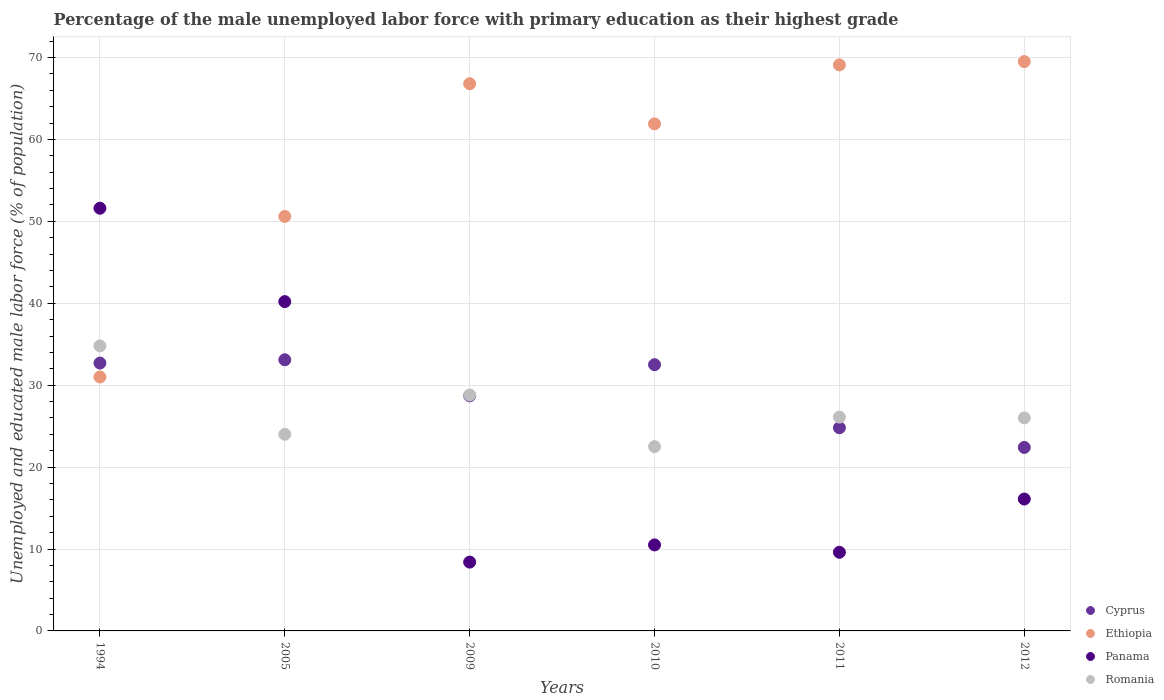What is the percentage of the unemployed male labor force with primary education in Romania in 2012?
Ensure brevity in your answer.  26. Across all years, what is the maximum percentage of the unemployed male labor force with primary education in Panama?
Provide a short and direct response. 51.6. Across all years, what is the minimum percentage of the unemployed male labor force with primary education in Ethiopia?
Give a very brief answer. 31. In which year was the percentage of the unemployed male labor force with primary education in Ethiopia maximum?
Your answer should be very brief. 2012. In which year was the percentage of the unemployed male labor force with primary education in Ethiopia minimum?
Make the answer very short. 1994. What is the total percentage of the unemployed male labor force with primary education in Romania in the graph?
Your answer should be very brief. 162.2. What is the difference between the percentage of the unemployed male labor force with primary education in Ethiopia in 1994 and that in 2010?
Provide a short and direct response. -30.9. What is the difference between the percentage of the unemployed male labor force with primary education in Panama in 2009 and the percentage of the unemployed male labor force with primary education in Cyprus in 2012?
Provide a short and direct response. -14. What is the average percentage of the unemployed male labor force with primary education in Cyprus per year?
Provide a succinct answer. 29.03. In the year 2012, what is the difference between the percentage of the unemployed male labor force with primary education in Panama and percentage of the unemployed male labor force with primary education in Cyprus?
Your answer should be compact. -6.3. What is the ratio of the percentage of the unemployed male labor force with primary education in Panama in 2010 to that in 2012?
Give a very brief answer. 0.65. Is the percentage of the unemployed male labor force with primary education in Panama in 2005 less than that in 2011?
Make the answer very short. No. Is the difference between the percentage of the unemployed male labor force with primary education in Panama in 2010 and 2011 greater than the difference between the percentage of the unemployed male labor force with primary education in Cyprus in 2010 and 2011?
Your answer should be compact. No. What is the difference between the highest and the second highest percentage of the unemployed male labor force with primary education in Ethiopia?
Keep it short and to the point. 0.4. What is the difference between the highest and the lowest percentage of the unemployed male labor force with primary education in Panama?
Your response must be concise. 43.2. In how many years, is the percentage of the unemployed male labor force with primary education in Romania greater than the average percentage of the unemployed male labor force with primary education in Romania taken over all years?
Ensure brevity in your answer.  2. Is the sum of the percentage of the unemployed male labor force with primary education in Ethiopia in 2005 and 2011 greater than the maximum percentage of the unemployed male labor force with primary education in Romania across all years?
Keep it short and to the point. Yes. Is it the case that in every year, the sum of the percentage of the unemployed male labor force with primary education in Ethiopia and percentage of the unemployed male labor force with primary education in Cyprus  is greater than the sum of percentage of the unemployed male labor force with primary education in Panama and percentage of the unemployed male labor force with primary education in Romania?
Keep it short and to the point. Yes. Is it the case that in every year, the sum of the percentage of the unemployed male labor force with primary education in Ethiopia and percentage of the unemployed male labor force with primary education in Panama  is greater than the percentage of the unemployed male labor force with primary education in Cyprus?
Your response must be concise. Yes. Does the percentage of the unemployed male labor force with primary education in Ethiopia monotonically increase over the years?
Provide a succinct answer. No. Is the percentage of the unemployed male labor force with primary education in Cyprus strictly greater than the percentage of the unemployed male labor force with primary education in Ethiopia over the years?
Offer a very short reply. No. How many dotlines are there?
Give a very brief answer. 4. Are the values on the major ticks of Y-axis written in scientific E-notation?
Ensure brevity in your answer.  No. Does the graph contain grids?
Ensure brevity in your answer.  Yes. Where does the legend appear in the graph?
Keep it short and to the point. Bottom right. How many legend labels are there?
Keep it short and to the point. 4. What is the title of the graph?
Offer a very short reply. Percentage of the male unemployed labor force with primary education as their highest grade. Does "Angola" appear as one of the legend labels in the graph?
Keep it short and to the point. No. What is the label or title of the Y-axis?
Provide a succinct answer. Unemployed and educated male labor force (% of population). What is the Unemployed and educated male labor force (% of population) of Cyprus in 1994?
Provide a short and direct response. 32.7. What is the Unemployed and educated male labor force (% of population) in Panama in 1994?
Offer a terse response. 51.6. What is the Unemployed and educated male labor force (% of population) of Romania in 1994?
Give a very brief answer. 34.8. What is the Unemployed and educated male labor force (% of population) of Cyprus in 2005?
Your answer should be compact. 33.1. What is the Unemployed and educated male labor force (% of population) in Ethiopia in 2005?
Your answer should be very brief. 50.6. What is the Unemployed and educated male labor force (% of population) of Panama in 2005?
Provide a succinct answer. 40.2. What is the Unemployed and educated male labor force (% of population) of Cyprus in 2009?
Your answer should be compact. 28.7. What is the Unemployed and educated male labor force (% of population) in Ethiopia in 2009?
Give a very brief answer. 66.8. What is the Unemployed and educated male labor force (% of population) of Panama in 2009?
Provide a short and direct response. 8.4. What is the Unemployed and educated male labor force (% of population) in Romania in 2009?
Offer a terse response. 28.8. What is the Unemployed and educated male labor force (% of population) of Cyprus in 2010?
Make the answer very short. 32.5. What is the Unemployed and educated male labor force (% of population) in Ethiopia in 2010?
Provide a short and direct response. 61.9. What is the Unemployed and educated male labor force (% of population) in Romania in 2010?
Your answer should be compact. 22.5. What is the Unemployed and educated male labor force (% of population) in Cyprus in 2011?
Offer a terse response. 24.8. What is the Unemployed and educated male labor force (% of population) of Ethiopia in 2011?
Provide a short and direct response. 69.1. What is the Unemployed and educated male labor force (% of population) in Panama in 2011?
Give a very brief answer. 9.6. What is the Unemployed and educated male labor force (% of population) in Romania in 2011?
Give a very brief answer. 26.1. What is the Unemployed and educated male labor force (% of population) of Cyprus in 2012?
Your answer should be compact. 22.4. What is the Unemployed and educated male labor force (% of population) in Ethiopia in 2012?
Keep it short and to the point. 69.5. What is the Unemployed and educated male labor force (% of population) of Panama in 2012?
Ensure brevity in your answer.  16.1. What is the Unemployed and educated male labor force (% of population) of Romania in 2012?
Ensure brevity in your answer.  26. Across all years, what is the maximum Unemployed and educated male labor force (% of population) in Cyprus?
Your answer should be compact. 33.1. Across all years, what is the maximum Unemployed and educated male labor force (% of population) of Ethiopia?
Give a very brief answer. 69.5. Across all years, what is the maximum Unemployed and educated male labor force (% of population) of Panama?
Ensure brevity in your answer.  51.6. Across all years, what is the maximum Unemployed and educated male labor force (% of population) in Romania?
Offer a terse response. 34.8. Across all years, what is the minimum Unemployed and educated male labor force (% of population) in Cyprus?
Ensure brevity in your answer.  22.4. Across all years, what is the minimum Unemployed and educated male labor force (% of population) of Ethiopia?
Offer a very short reply. 31. Across all years, what is the minimum Unemployed and educated male labor force (% of population) of Panama?
Give a very brief answer. 8.4. What is the total Unemployed and educated male labor force (% of population) of Cyprus in the graph?
Provide a succinct answer. 174.2. What is the total Unemployed and educated male labor force (% of population) of Ethiopia in the graph?
Give a very brief answer. 348.9. What is the total Unemployed and educated male labor force (% of population) of Panama in the graph?
Your answer should be compact. 136.4. What is the total Unemployed and educated male labor force (% of population) in Romania in the graph?
Ensure brevity in your answer.  162.2. What is the difference between the Unemployed and educated male labor force (% of population) in Ethiopia in 1994 and that in 2005?
Your answer should be very brief. -19.6. What is the difference between the Unemployed and educated male labor force (% of population) in Romania in 1994 and that in 2005?
Your answer should be very brief. 10.8. What is the difference between the Unemployed and educated male labor force (% of population) in Ethiopia in 1994 and that in 2009?
Offer a terse response. -35.8. What is the difference between the Unemployed and educated male labor force (% of population) in Panama in 1994 and that in 2009?
Provide a succinct answer. 43.2. What is the difference between the Unemployed and educated male labor force (% of population) in Romania in 1994 and that in 2009?
Offer a very short reply. 6. What is the difference between the Unemployed and educated male labor force (% of population) of Cyprus in 1994 and that in 2010?
Keep it short and to the point. 0.2. What is the difference between the Unemployed and educated male labor force (% of population) of Ethiopia in 1994 and that in 2010?
Your response must be concise. -30.9. What is the difference between the Unemployed and educated male labor force (% of population) of Panama in 1994 and that in 2010?
Offer a very short reply. 41.1. What is the difference between the Unemployed and educated male labor force (% of population) in Romania in 1994 and that in 2010?
Your answer should be compact. 12.3. What is the difference between the Unemployed and educated male labor force (% of population) in Cyprus in 1994 and that in 2011?
Offer a terse response. 7.9. What is the difference between the Unemployed and educated male labor force (% of population) in Ethiopia in 1994 and that in 2011?
Make the answer very short. -38.1. What is the difference between the Unemployed and educated male labor force (% of population) of Panama in 1994 and that in 2011?
Your answer should be compact. 42. What is the difference between the Unemployed and educated male labor force (% of population) of Ethiopia in 1994 and that in 2012?
Offer a very short reply. -38.5. What is the difference between the Unemployed and educated male labor force (% of population) of Panama in 1994 and that in 2012?
Your response must be concise. 35.5. What is the difference between the Unemployed and educated male labor force (% of population) in Cyprus in 2005 and that in 2009?
Offer a very short reply. 4.4. What is the difference between the Unemployed and educated male labor force (% of population) in Ethiopia in 2005 and that in 2009?
Give a very brief answer. -16.2. What is the difference between the Unemployed and educated male labor force (% of population) in Panama in 2005 and that in 2009?
Provide a succinct answer. 31.8. What is the difference between the Unemployed and educated male labor force (% of population) of Romania in 2005 and that in 2009?
Your answer should be compact. -4.8. What is the difference between the Unemployed and educated male labor force (% of population) of Ethiopia in 2005 and that in 2010?
Offer a very short reply. -11.3. What is the difference between the Unemployed and educated male labor force (% of population) in Panama in 2005 and that in 2010?
Make the answer very short. 29.7. What is the difference between the Unemployed and educated male labor force (% of population) in Cyprus in 2005 and that in 2011?
Offer a terse response. 8.3. What is the difference between the Unemployed and educated male labor force (% of population) in Ethiopia in 2005 and that in 2011?
Your answer should be compact. -18.5. What is the difference between the Unemployed and educated male labor force (% of population) in Panama in 2005 and that in 2011?
Make the answer very short. 30.6. What is the difference between the Unemployed and educated male labor force (% of population) of Romania in 2005 and that in 2011?
Ensure brevity in your answer.  -2.1. What is the difference between the Unemployed and educated male labor force (% of population) of Ethiopia in 2005 and that in 2012?
Your answer should be very brief. -18.9. What is the difference between the Unemployed and educated male labor force (% of population) in Panama in 2005 and that in 2012?
Your response must be concise. 24.1. What is the difference between the Unemployed and educated male labor force (% of population) in Cyprus in 2009 and that in 2010?
Your answer should be compact. -3.8. What is the difference between the Unemployed and educated male labor force (% of population) in Ethiopia in 2009 and that in 2010?
Offer a terse response. 4.9. What is the difference between the Unemployed and educated male labor force (% of population) in Romania in 2009 and that in 2010?
Give a very brief answer. 6.3. What is the difference between the Unemployed and educated male labor force (% of population) of Cyprus in 2009 and that in 2011?
Offer a very short reply. 3.9. What is the difference between the Unemployed and educated male labor force (% of population) of Panama in 2009 and that in 2011?
Provide a short and direct response. -1.2. What is the difference between the Unemployed and educated male labor force (% of population) of Romania in 2009 and that in 2011?
Offer a very short reply. 2.7. What is the difference between the Unemployed and educated male labor force (% of population) in Panama in 2010 and that in 2011?
Keep it short and to the point. 0.9. What is the difference between the Unemployed and educated male labor force (% of population) of Romania in 2010 and that in 2011?
Provide a short and direct response. -3.6. What is the difference between the Unemployed and educated male labor force (% of population) in Romania in 2010 and that in 2012?
Your answer should be compact. -3.5. What is the difference between the Unemployed and educated male labor force (% of population) of Panama in 2011 and that in 2012?
Provide a succinct answer. -6.5. What is the difference between the Unemployed and educated male labor force (% of population) in Romania in 2011 and that in 2012?
Give a very brief answer. 0.1. What is the difference between the Unemployed and educated male labor force (% of population) of Cyprus in 1994 and the Unemployed and educated male labor force (% of population) of Ethiopia in 2005?
Offer a very short reply. -17.9. What is the difference between the Unemployed and educated male labor force (% of population) of Cyprus in 1994 and the Unemployed and educated male labor force (% of population) of Romania in 2005?
Provide a succinct answer. 8.7. What is the difference between the Unemployed and educated male labor force (% of population) of Ethiopia in 1994 and the Unemployed and educated male labor force (% of population) of Panama in 2005?
Ensure brevity in your answer.  -9.2. What is the difference between the Unemployed and educated male labor force (% of population) of Ethiopia in 1994 and the Unemployed and educated male labor force (% of population) of Romania in 2005?
Provide a succinct answer. 7. What is the difference between the Unemployed and educated male labor force (% of population) in Panama in 1994 and the Unemployed and educated male labor force (% of population) in Romania in 2005?
Offer a terse response. 27.6. What is the difference between the Unemployed and educated male labor force (% of population) of Cyprus in 1994 and the Unemployed and educated male labor force (% of population) of Ethiopia in 2009?
Make the answer very short. -34.1. What is the difference between the Unemployed and educated male labor force (% of population) of Cyprus in 1994 and the Unemployed and educated male labor force (% of population) of Panama in 2009?
Your answer should be compact. 24.3. What is the difference between the Unemployed and educated male labor force (% of population) of Ethiopia in 1994 and the Unemployed and educated male labor force (% of population) of Panama in 2009?
Provide a succinct answer. 22.6. What is the difference between the Unemployed and educated male labor force (% of population) of Panama in 1994 and the Unemployed and educated male labor force (% of population) of Romania in 2009?
Ensure brevity in your answer.  22.8. What is the difference between the Unemployed and educated male labor force (% of population) in Cyprus in 1994 and the Unemployed and educated male labor force (% of population) in Ethiopia in 2010?
Offer a terse response. -29.2. What is the difference between the Unemployed and educated male labor force (% of population) in Cyprus in 1994 and the Unemployed and educated male labor force (% of population) in Panama in 2010?
Give a very brief answer. 22.2. What is the difference between the Unemployed and educated male labor force (% of population) of Cyprus in 1994 and the Unemployed and educated male labor force (% of population) of Romania in 2010?
Your response must be concise. 10.2. What is the difference between the Unemployed and educated male labor force (% of population) in Ethiopia in 1994 and the Unemployed and educated male labor force (% of population) in Romania in 2010?
Offer a very short reply. 8.5. What is the difference between the Unemployed and educated male labor force (% of population) of Panama in 1994 and the Unemployed and educated male labor force (% of population) of Romania in 2010?
Make the answer very short. 29.1. What is the difference between the Unemployed and educated male labor force (% of population) of Cyprus in 1994 and the Unemployed and educated male labor force (% of population) of Ethiopia in 2011?
Offer a very short reply. -36.4. What is the difference between the Unemployed and educated male labor force (% of population) in Cyprus in 1994 and the Unemployed and educated male labor force (% of population) in Panama in 2011?
Provide a succinct answer. 23.1. What is the difference between the Unemployed and educated male labor force (% of population) in Ethiopia in 1994 and the Unemployed and educated male labor force (% of population) in Panama in 2011?
Make the answer very short. 21.4. What is the difference between the Unemployed and educated male labor force (% of population) in Cyprus in 1994 and the Unemployed and educated male labor force (% of population) in Ethiopia in 2012?
Keep it short and to the point. -36.8. What is the difference between the Unemployed and educated male labor force (% of population) of Ethiopia in 1994 and the Unemployed and educated male labor force (% of population) of Panama in 2012?
Provide a succinct answer. 14.9. What is the difference between the Unemployed and educated male labor force (% of population) in Ethiopia in 1994 and the Unemployed and educated male labor force (% of population) in Romania in 2012?
Give a very brief answer. 5. What is the difference between the Unemployed and educated male labor force (% of population) of Panama in 1994 and the Unemployed and educated male labor force (% of population) of Romania in 2012?
Ensure brevity in your answer.  25.6. What is the difference between the Unemployed and educated male labor force (% of population) of Cyprus in 2005 and the Unemployed and educated male labor force (% of population) of Ethiopia in 2009?
Make the answer very short. -33.7. What is the difference between the Unemployed and educated male labor force (% of population) in Cyprus in 2005 and the Unemployed and educated male labor force (% of population) in Panama in 2009?
Your response must be concise. 24.7. What is the difference between the Unemployed and educated male labor force (% of population) in Cyprus in 2005 and the Unemployed and educated male labor force (% of population) in Romania in 2009?
Provide a succinct answer. 4.3. What is the difference between the Unemployed and educated male labor force (% of population) of Ethiopia in 2005 and the Unemployed and educated male labor force (% of population) of Panama in 2009?
Provide a succinct answer. 42.2. What is the difference between the Unemployed and educated male labor force (% of population) of Ethiopia in 2005 and the Unemployed and educated male labor force (% of population) of Romania in 2009?
Your answer should be very brief. 21.8. What is the difference between the Unemployed and educated male labor force (% of population) in Panama in 2005 and the Unemployed and educated male labor force (% of population) in Romania in 2009?
Your answer should be compact. 11.4. What is the difference between the Unemployed and educated male labor force (% of population) in Cyprus in 2005 and the Unemployed and educated male labor force (% of population) in Ethiopia in 2010?
Give a very brief answer. -28.8. What is the difference between the Unemployed and educated male labor force (% of population) of Cyprus in 2005 and the Unemployed and educated male labor force (% of population) of Panama in 2010?
Your answer should be compact. 22.6. What is the difference between the Unemployed and educated male labor force (% of population) in Ethiopia in 2005 and the Unemployed and educated male labor force (% of population) in Panama in 2010?
Make the answer very short. 40.1. What is the difference between the Unemployed and educated male labor force (% of population) of Ethiopia in 2005 and the Unemployed and educated male labor force (% of population) of Romania in 2010?
Provide a succinct answer. 28.1. What is the difference between the Unemployed and educated male labor force (% of population) of Cyprus in 2005 and the Unemployed and educated male labor force (% of population) of Ethiopia in 2011?
Offer a very short reply. -36. What is the difference between the Unemployed and educated male labor force (% of population) of Cyprus in 2005 and the Unemployed and educated male labor force (% of population) of Panama in 2011?
Offer a terse response. 23.5. What is the difference between the Unemployed and educated male labor force (% of population) in Panama in 2005 and the Unemployed and educated male labor force (% of population) in Romania in 2011?
Give a very brief answer. 14.1. What is the difference between the Unemployed and educated male labor force (% of population) of Cyprus in 2005 and the Unemployed and educated male labor force (% of population) of Ethiopia in 2012?
Make the answer very short. -36.4. What is the difference between the Unemployed and educated male labor force (% of population) in Cyprus in 2005 and the Unemployed and educated male labor force (% of population) in Romania in 2012?
Your answer should be very brief. 7.1. What is the difference between the Unemployed and educated male labor force (% of population) of Ethiopia in 2005 and the Unemployed and educated male labor force (% of population) of Panama in 2012?
Offer a terse response. 34.5. What is the difference between the Unemployed and educated male labor force (% of population) of Ethiopia in 2005 and the Unemployed and educated male labor force (% of population) of Romania in 2012?
Your answer should be compact. 24.6. What is the difference between the Unemployed and educated male labor force (% of population) of Cyprus in 2009 and the Unemployed and educated male labor force (% of population) of Ethiopia in 2010?
Your answer should be compact. -33.2. What is the difference between the Unemployed and educated male labor force (% of population) of Cyprus in 2009 and the Unemployed and educated male labor force (% of population) of Romania in 2010?
Give a very brief answer. 6.2. What is the difference between the Unemployed and educated male labor force (% of population) in Ethiopia in 2009 and the Unemployed and educated male labor force (% of population) in Panama in 2010?
Make the answer very short. 56.3. What is the difference between the Unemployed and educated male labor force (% of population) in Ethiopia in 2009 and the Unemployed and educated male labor force (% of population) in Romania in 2010?
Keep it short and to the point. 44.3. What is the difference between the Unemployed and educated male labor force (% of population) of Panama in 2009 and the Unemployed and educated male labor force (% of population) of Romania in 2010?
Your answer should be compact. -14.1. What is the difference between the Unemployed and educated male labor force (% of population) of Cyprus in 2009 and the Unemployed and educated male labor force (% of population) of Ethiopia in 2011?
Keep it short and to the point. -40.4. What is the difference between the Unemployed and educated male labor force (% of population) in Ethiopia in 2009 and the Unemployed and educated male labor force (% of population) in Panama in 2011?
Your answer should be compact. 57.2. What is the difference between the Unemployed and educated male labor force (% of population) in Ethiopia in 2009 and the Unemployed and educated male labor force (% of population) in Romania in 2011?
Offer a very short reply. 40.7. What is the difference between the Unemployed and educated male labor force (% of population) in Panama in 2009 and the Unemployed and educated male labor force (% of population) in Romania in 2011?
Offer a terse response. -17.7. What is the difference between the Unemployed and educated male labor force (% of population) of Cyprus in 2009 and the Unemployed and educated male labor force (% of population) of Ethiopia in 2012?
Your answer should be very brief. -40.8. What is the difference between the Unemployed and educated male labor force (% of population) of Cyprus in 2009 and the Unemployed and educated male labor force (% of population) of Romania in 2012?
Offer a very short reply. 2.7. What is the difference between the Unemployed and educated male labor force (% of population) in Ethiopia in 2009 and the Unemployed and educated male labor force (% of population) in Panama in 2012?
Offer a terse response. 50.7. What is the difference between the Unemployed and educated male labor force (% of population) in Ethiopia in 2009 and the Unemployed and educated male labor force (% of population) in Romania in 2012?
Provide a short and direct response. 40.8. What is the difference between the Unemployed and educated male labor force (% of population) of Panama in 2009 and the Unemployed and educated male labor force (% of population) of Romania in 2012?
Provide a short and direct response. -17.6. What is the difference between the Unemployed and educated male labor force (% of population) of Cyprus in 2010 and the Unemployed and educated male labor force (% of population) of Ethiopia in 2011?
Offer a terse response. -36.6. What is the difference between the Unemployed and educated male labor force (% of population) of Cyprus in 2010 and the Unemployed and educated male labor force (% of population) of Panama in 2011?
Provide a succinct answer. 22.9. What is the difference between the Unemployed and educated male labor force (% of population) of Cyprus in 2010 and the Unemployed and educated male labor force (% of population) of Romania in 2011?
Ensure brevity in your answer.  6.4. What is the difference between the Unemployed and educated male labor force (% of population) of Ethiopia in 2010 and the Unemployed and educated male labor force (% of population) of Panama in 2011?
Your answer should be compact. 52.3. What is the difference between the Unemployed and educated male labor force (% of population) of Ethiopia in 2010 and the Unemployed and educated male labor force (% of population) of Romania in 2011?
Your response must be concise. 35.8. What is the difference between the Unemployed and educated male labor force (% of population) in Panama in 2010 and the Unemployed and educated male labor force (% of population) in Romania in 2011?
Your answer should be very brief. -15.6. What is the difference between the Unemployed and educated male labor force (% of population) of Cyprus in 2010 and the Unemployed and educated male labor force (% of population) of Ethiopia in 2012?
Provide a succinct answer. -37. What is the difference between the Unemployed and educated male labor force (% of population) in Ethiopia in 2010 and the Unemployed and educated male labor force (% of population) in Panama in 2012?
Make the answer very short. 45.8. What is the difference between the Unemployed and educated male labor force (% of population) of Ethiopia in 2010 and the Unemployed and educated male labor force (% of population) of Romania in 2012?
Offer a very short reply. 35.9. What is the difference between the Unemployed and educated male labor force (% of population) in Panama in 2010 and the Unemployed and educated male labor force (% of population) in Romania in 2012?
Provide a short and direct response. -15.5. What is the difference between the Unemployed and educated male labor force (% of population) of Cyprus in 2011 and the Unemployed and educated male labor force (% of population) of Ethiopia in 2012?
Ensure brevity in your answer.  -44.7. What is the difference between the Unemployed and educated male labor force (% of population) of Ethiopia in 2011 and the Unemployed and educated male labor force (% of population) of Panama in 2012?
Your answer should be compact. 53. What is the difference between the Unemployed and educated male labor force (% of population) in Ethiopia in 2011 and the Unemployed and educated male labor force (% of population) in Romania in 2012?
Offer a very short reply. 43.1. What is the difference between the Unemployed and educated male labor force (% of population) of Panama in 2011 and the Unemployed and educated male labor force (% of population) of Romania in 2012?
Your answer should be compact. -16.4. What is the average Unemployed and educated male labor force (% of population) in Cyprus per year?
Your answer should be very brief. 29.03. What is the average Unemployed and educated male labor force (% of population) of Ethiopia per year?
Offer a very short reply. 58.15. What is the average Unemployed and educated male labor force (% of population) in Panama per year?
Ensure brevity in your answer.  22.73. What is the average Unemployed and educated male labor force (% of population) in Romania per year?
Provide a succinct answer. 27.03. In the year 1994, what is the difference between the Unemployed and educated male labor force (% of population) in Cyprus and Unemployed and educated male labor force (% of population) in Panama?
Offer a terse response. -18.9. In the year 1994, what is the difference between the Unemployed and educated male labor force (% of population) in Ethiopia and Unemployed and educated male labor force (% of population) in Panama?
Make the answer very short. -20.6. In the year 2005, what is the difference between the Unemployed and educated male labor force (% of population) of Cyprus and Unemployed and educated male labor force (% of population) of Ethiopia?
Offer a very short reply. -17.5. In the year 2005, what is the difference between the Unemployed and educated male labor force (% of population) of Cyprus and Unemployed and educated male labor force (% of population) of Panama?
Keep it short and to the point. -7.1. In the year 2005, what is the difference between the Unemployed and educated male labor force (% of population) in Ethiopia and Unemployed and educated male labor force (% of population) in Panama?
Your answer should be very brief. 10.4. In the year 2005, what is the difference between the Unemployed and educated male labor force (% of population) of Ethiopia and Unemployed and educated male labor force (% of population) of Romania?
Give a very brief answer. 26.6. In the year 2009, what is the difference between the Unemployed and educated male labor force (% of population) in Cyprus and Unemployed and educated male labor force (% of population) in Ethiopia?
Provide a succinct answer. -38.1. In the year 2009, what is the difference between the Unemployed and educated male labor force (% of population) in Cyprus and Unemployed and educated male labor force (% of population) in Panama?
Keep it short and to the point. 20.3. In the year 2009, what is the difference between the Unemployed and educated male labor force (% of population) of Cyprus and Unemployed and educated male labor force (% of population) of Romania?
Give a very brief answer. -0.1. In the year 2009, what is the difference between the Unemployed and educated male labor force (% of population) of Ethiopia and Unemployed and educated male labor force (% of population) of Panama?
Make the answer very short. 58.4. In the year 2009, what is the difference between the Unemployed and educated male labor force (% of population) in Ethiopia and Unemployed and educated male labor force (% of population) in Romania?
Keep it short and to the point. 38. In the year 2009, what is the difference between the Unemployed and educated male labor force (% of population) in Panama and Unemployed and educated male labor force (% of population) in Romania?
Ensure brevity in your answer.  -20.4. In the year 2010, what is the difference between the Unemployed and educated male labor force (% of population) in Cyprus and Unemployed and educated male labor force (% of population) in Ethiopia?
Offer a very short reply. -29.4. In the year 2010, what is the difference between the Unemployed and educated male labor force (% of population) in Cyprus and Unemployed and educated male labor force (% of population) in Romania?
Offer a terse response. 10. In the year 2010, what is the difference between the Unemployed and educated male labor force (% of population) of Ethiopia and Unemployed and educated male labor force (% of population) of Panama?
Provide a succinct answer. 51.4. In the year 2010, what is the difference between the Unemployed and educated male labor force (% of population) in Ethiopia and Unemployed and educated male labor force (% of population) in Romania?
Ensure brevity in your answer.  39.4. In the year 2010, what is the difference between the Unemployed and educated male labor force (% of population) of Panama and Unemployed and educated male labor force (% of population) of Romania?
Give a very brief answer. -12. In the year 2011, what is the difference between the Unemployed and educated male labor force (% of population) in Cyprus and Unemployed and educated male labor force (% of population) in Ethiopia?
Offer a very short reply. -44.3. In the year 2011, what is the difference between the Unemployed and educated male labor force (% of population) of Cyprus and Unemployed and educated male labor force (% of population) of Panama?
Offer a very short reply. 15.2. In the year 2011, what is the difference between the Unemployed and educated male labor force (% of population) in Cyprus and Unemployed and educated male labor force (% of population) in Romania?
Your answer should be compact. -1.3. In the year 2011, what is the difference between the Unemployed and educated male labor force (% of population) in Ethiopia and Unemployed and educated male labor force (% of population) in Panama?
Your answer should be compact. 59.5. In the year 2011, what is the difference between the Unemployed and educated male labor force (% of population) of Panama and Unemployed and educated male labor force (% of population) of Romania?
Your answer should be compact. -16.5. In the year 2012, what is the difference between the Unemployed and educated male labor force (% of population) in Cyprus and Unemployed and educated male labor force (% of population) in Ethiopia?
Your answer should be compact. -47.1. In the year 2012, what is the difference between the Unemployed and educated male labor force (% of population) of Cyprus and Unemployed and educated male labor force (% of population) of Panama?
Your response must be concise. 6.3. In the year 2012, what is the difference between the Unemployed and educated male labor force (% of population) in Cyprus and Unemployed and educated male labor force (% of population) in Romania?
Make the answer very short. -3.6. In the year 2012, what is the difference between the Unemployed and educated male labor force (% of population) in Ethiopia and Unemployed and educated male labor force (% of population) in Panama?
Your response must be concise. 53.4. In the year 2012, what is the difference between the Unemployed and educated male labor force (% of population) in Ethiopia and Unemployed and educated male labor force (% of population) in Romania?
Give a very brief answer. 43.5. What is the ratio of the Unemployed and educated male labor force (% of population) in Cyprus in 1994 to that in 2005?
Your answer should be compact. 0.99. What is the ratio of the Unemployed and educated male labor force (% of population) in Ethiopia in 1994 to that in 2005?
Make the answer very short. 0.61. What is the ratio of the Unemployed and educated male labor force (% of population) in Panama in 1994 to that in 2005?
Your response must be concise. 1.28. What is the ratio of the Unemployed and educated male labor force (% of population) of Romania in 1994 to that in 2005?
Ensure brevity in your answer.  1.45. What is the ratio of the Unemployed and educated male labor force (% of population) of Cyprus in 1994 to that in 2009?
Make the answer very short. 1.14. What is the ratio of the Unemployed and educated male labor force (% of population) of Ethiopia in 1994 to that in 2009?
Your answer should be compact. 0.46. What is the ratio of the Unemployed and educated male labor force (% of population) of Panama in 1994 to that in 2009?
Offer a terse response. 6.14. What is the ratio of the Unemployed and educated male labor force (% of population) of Romania in 1994 to that in 2009?
Your answer should be compact. 1.21. What is the ratio of the Unemployed and educated male labor force (% of population) in Ethiopia in 1994 to that in 2010?
Your answer should be very brief. 0.5. What is the ratio of the Unemployed and educated male labor force (% of population) in Panama in 1994 to that in 2010?
Make the answer very short. 4.91. What is the ratio of the Unemployed and educated male labor force (% of population) of Romania in 1994 to that in 2010?
Provide a short and direct response. 1.55. What is the ratio of the Unemployed and educated male labor force (% of population) of Cyprus in 1994 to that in 2011?
Ensure brevity in your answer.  1.32. What is the ratio of the Unemployed and educated male labor force (% of population) of Ethiopia in 1994 to that in 2011?
Offer a terse response. 0.45. What is the ratio of the Unemployed and educated male labor force (% of population) in Panama in 1994 to that in 2011?
Keep it short and to the point. 5.38. What is the ratio of the Unemployed and educated male labor force (% of population) of Romania in 1994 to that in 2011?
Your answer should be compact. 1.33. What is the ratio of the Unemployed and educated male labor force (% of population) in Cyprus in 1994 to that in 2012?
Your answer should be compact. 1.46. What is the ratio of the Unemployed and educated male labor force (% of population) of Ethiopia in 1994 to that in 2012?
Your answer should be very brief. 0.45. What is the ratio of the Unemployed and educated male labor force (% of population) in Panama in 1994 to that in 2012?
Give a very brief answer. 3.21. What is the ratio of the Unemployed and educated male labor force (% of population) of Romania in 1994 to that in 2012?
Offer a very short reply. 1.34. What is the ratio of the Unemployed and educated male labor force (% of population) in Cyprus in 2005 to that in 2009?
Keep it short and to the point. 1.15. What is the ratio of the Unemployed and educated male labor force (% of population) of Ethiopia in 2005 to that in 2009?
Provide a succinct answer. 0.76. What is the ratio of the Unemployed and educated male labor force (% of population) of Panama in 2005 to that in 2009?
Your response must be concise. 4.79. What is the ratio of the Unemployed and educated male labor force (% of population) of Cyprus in 2005 to that in 2010?
Give a very brief answer. 1.02. What is the ratio of the Unemployed and educated male labor force (% of population) of Ethiopia in 2005 to that in 2010?
Keep it short and to the point. 0.82. What is the ratio of the Unemployed and educated male labor force (% of population) of Panama in 2005 to that in 2010?
Offer a terse response. 3.83. What is the ratio of the Unemployed and educated male labor force (% of population) of Romania in 2005 to that in 2010?
Provide a succinct answer. 1.07. What is the ratio of the Unemployed and educated male labor force (% of population) in Cyprus in 2005 to that in 2011?
Ensure brevity in your answer.  1.33. What is the ratio of the Unemployed and educated male labor force (% of population) in Ethiopia in 2005 to that in 2011?
Give a very brief answer. 0.73. What is the ratio of the Unemployed and educated male labor force (% of population) in Panama in 2005 to that in 2011?
Give a very brief answer. 4.19. What is the ratio of the Unemployed and educated male labor force (% of population) in Romania in 2005 to that in 2011?
Ensure brevity in your answer.  0.92. What is the ratio of the Unemployed and educated male labor force (% of population) of Cyprus in 2005 to that in 2012?
Your response must be concise. 1.48. What is the ratio of the Unemployed and educated male labor force (% of population) in Ethiopia in 2005 to that in 2012?
Provide a succinct answer. 0.73. What is the ratio of the Unemployed and educated male labor force (% of population) in Panama in 2005 to that in 2012?
Your response must be concise. 2.5. What is the ratio of the Unemployed and educated male labor force (% of population) in Romania in 2005 to that in 2012?
Offer a terse response. 0.92. What is the ratio of the Unemployed and educated male labor force (% of population) of Cyprus in 2009 to that in 2010?
Provide a succinct answer. 0.88. What is the ratio of the Unemployed and educated male labor force (% of population) in Ethiopia in 2009 to that in 2010?
Ensure brevity in your answer.  1.08. What is the ratio of the Unemployed and educated male labor force (% of population) of Panama in 2009 to that in 2010?
Keep it short and to the point. 0.8. What is the ratio of the Unemployed and educated male labor force (% of population) in Romania in 2009 to that in 2010?
Give a very brief answer. 1.28. What is the ratio of the Unemployed and educated male labor force (% of population) of Cyprus in 2009 to that in 2011?
Your answer should be very brief. 1.16. What is the ratio of the Unemployed and educated male labor force (% of population) in Ethiopia in 2009 to that in 2011?
Your answer should be compact. 0.97. What is the ratio of the Unemployed and educated male labor force (% of population) in Panama in 2009 to that in 2011?
Ensure brevity in your answer.  0.88. What is the ratio of the Unemployed and educated male labor force (% of population) of Romania in 2009 to that in 2011?
Keep it short and to the point. 1.1. What is the ratio of the Unemployed and educated male labor force (% of population) in Cyprus in 2009 to that in 2012?
Your answer should be very brief. 1.28. What is the ratio of the Unemployed and educated male labor force (% of population) in Ethiopia in 2009 to that in 2012?
Make the answer very short. 0.96. What is the ratio of the Unemployed and educated male labor force (% of population) of Panama in 2009 to that in 2012?
Offer a very short reply. 0.52. What is the ratio of the Unemployed and educated male labor force (% of population) of Romania in 2009 to that in 2012?
Give a very brief answer. 1.11. What is the ratio of the Unemployed and educated male labor force (% of population) in Cyprus in 2010 to that in 2011?
Offer a terse response. 1.31. What is the ratio of the Unemployed and educated male labor force (% of population) of Ethiopia in 2010 to that in 2011?
Keep it short and to the point. 0.9. What is the ratio of the Unemployed and educated male labor force (% of population) of Panama in 2010 to that in 2011?
Give a very brief answer. 1.09. What is the ratio of the Unemployed and educated male labor force (% of population) of Romania in 2010 to that in 2011?
Make the answer very short. 0.86. What is the ratio of the Unemployed and educated male labor force (% of population) in Cyprus in 2010 to that in 2012?
Offer a terse response. 1.45. What is the ratio of the Unemployed and educated male labor force (% of population) in Ethiopia in 2010 to that in 2012?
Keep it short and to the point. 0.89. What is the ratio of the Unemployed and educated male labor force (% of population) in Panama in 2010 to that in 2012?
Provide a short and direct response. 0.65. What is the ratio of the Unemployed and educated male labor force (% of population) in Romania in 2010 to that in 2012?
Your answer should be compact. 0.87. What is the ratio of the Unemployed and educated male labor force (% of population) of Cyprus in 2011 to that in 2012?
Make the answer very short. 1.11. What is the ratio of the Unemployed and educated male labor force (% of population) in Panama in 2011 to that in 2012?
Provide a succinct answer. 0.6. What is the ratio of the Unemployed and educated male labor force (% of population) in Romania in 2011 to that in 2012?
Your answer should be compact. 1. What is the difference between the highest and the second highest Unemployed and educated male labor force (% of population) of Panama?
Your response must be concise. 11.4. What is the difference between the highest and the lowest Unemployed and educated male labor force (% of population) in Ethiopia?
Provide a succinct answer. 38.5. What is the difference between the highest and the lowest Unemployed and educated male labor force (% of population) of Panama?
Keep it short and to the point. 43.2. 